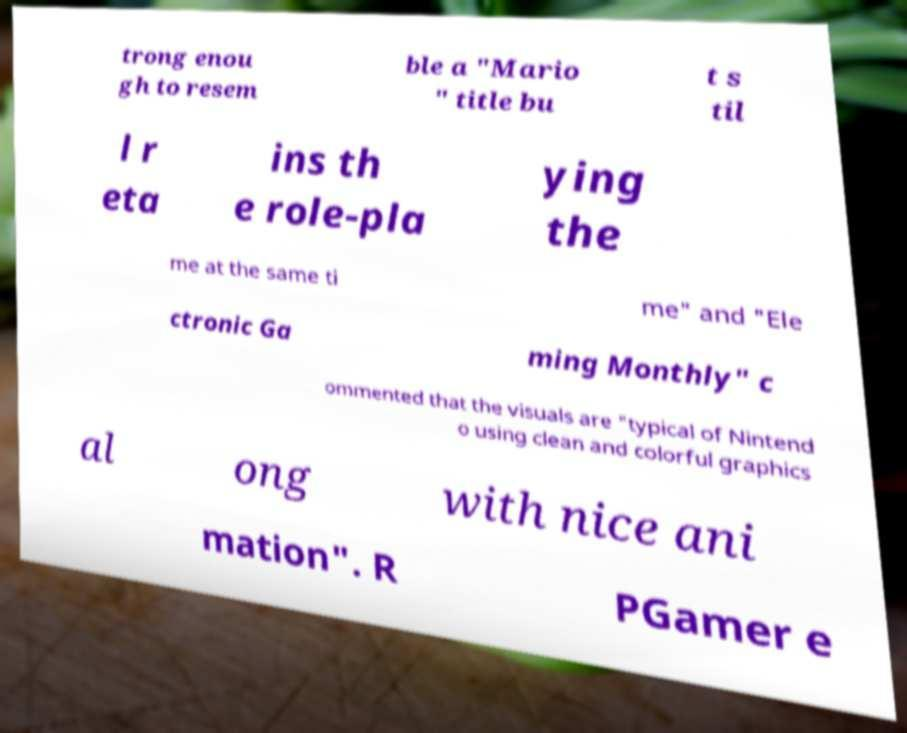What messages or text are displayed in this image? I need them in a readable, typed format. trong enou gh to resem ble a "Mario " title bu t s til l r eta ins th e role-pla ying the me at the same ti me" and "Ele ctronic Ga ming Monthly" c ommented that the visuals are "typical of Nintend o using clean and colorful graphics al ong with nice ani mation". R PGamer e 